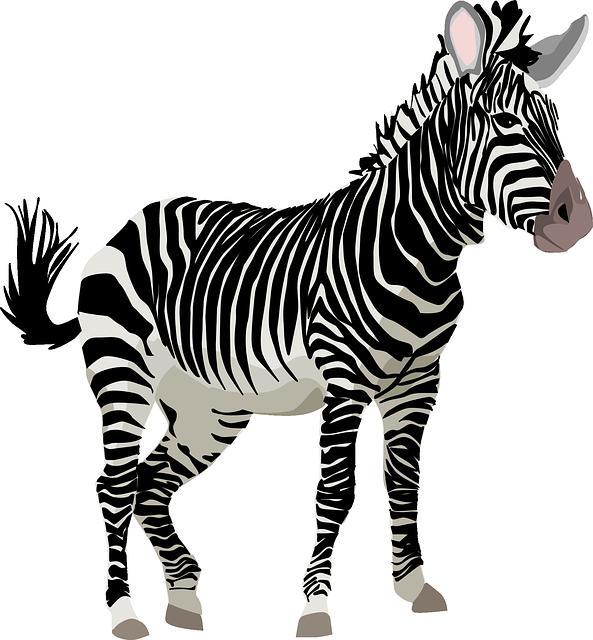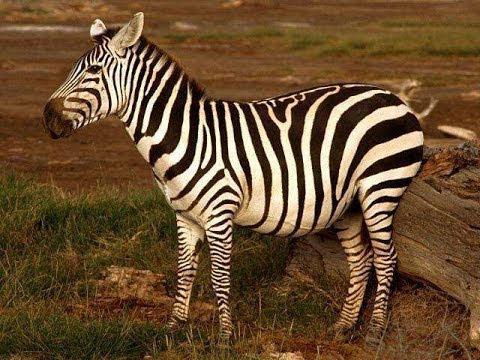The first image is the image on the left, the second image is the image on the right. Considering the images on both sides, is "A zebra has its head down eating the very short green grass." valid? Answer yes or no. No. The first image is the image on the left, the second image is the image on the right. Assess this claim about the two images: "In one image a lone zebra is standing and grazing in the grass.". Correct or not? Answer yes or no. No. 